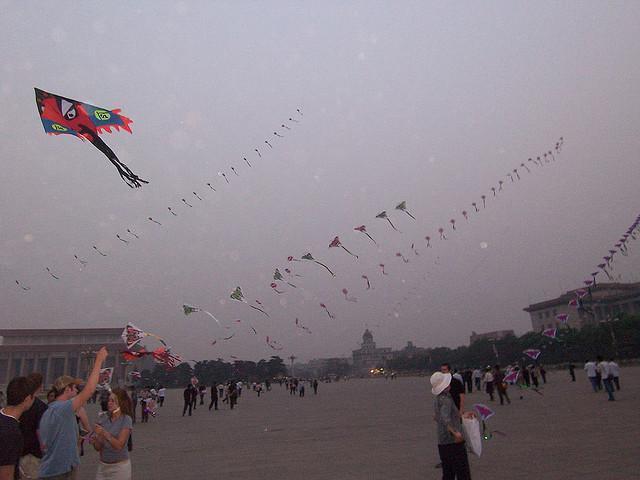How many kites are visible?
Give a very brief answer. 2. How many people can be seen?
Give a very brief answer. 5. 